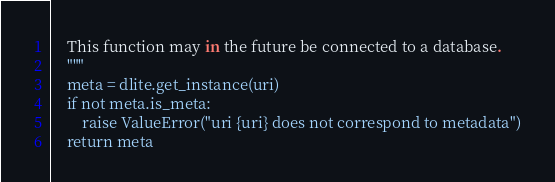Convert code to text. <code><loc_0><loc_0><loc_500><loc_500><_Python_>
    This function may in the future be connected to a database.
    """
    meta = dlite.get_instance(uri)
    if not meta.is_meta:
        raise ValueError("uri {uri} does not correspond to metadata")
    return meta
</code> 